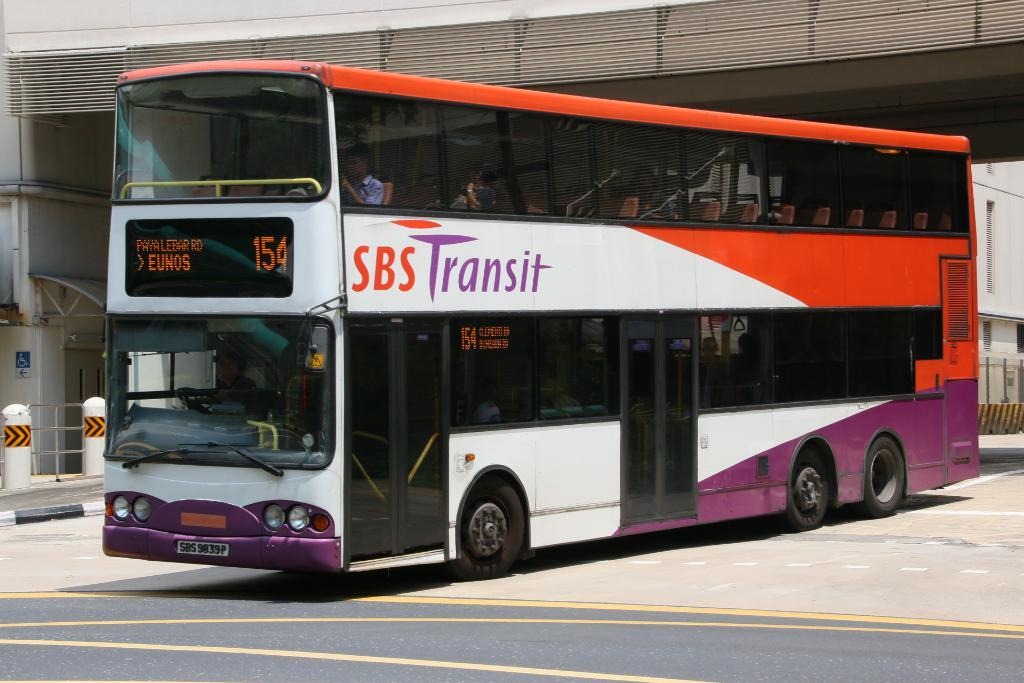What type of vehicle is present on the road in the image? There is a bus on the road in the image. Who or what can be found inside the bus? There are people inside the bus. What structures are visible on the backside of the bus? A building, a fence, poles, and a signboard are visible on the backside of the bus. What type of grain is being harvested by the farmer in the image? There is no farmer or grain present in the image; it features a bus on the road with people inside and structures visible on the backside. 